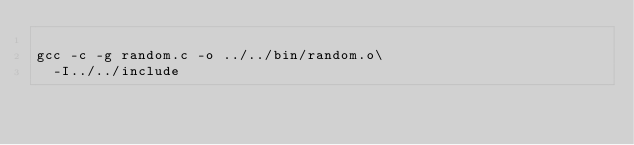Convert code to text. <code><loc_0><loc_0><loc_500><loc_500><_Bash_>
gcc -c -g random.c -o ../../bin/random.o\
  -I../../include


</code> 